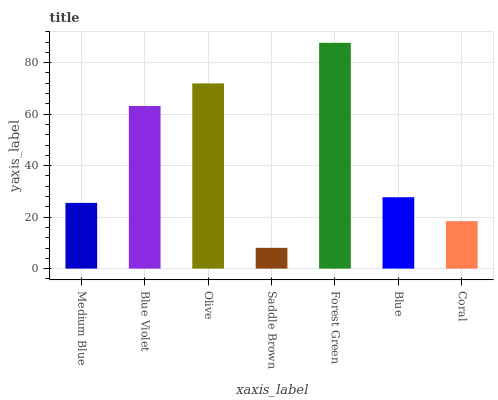Is Saddle Brown the minimum?
Answer yes or no. Yes. Is Forest Green the maximum?
Answer yes or no. Yes. Is Blue Violet the minimum?
Answer yes or no. No. Is Blue Violet the maximum?
Answer yes or no. No. Is Blue Violet greater than Medium Blue?
Answer yes or no. Yes. Is Medium Blue less than Blue Violet?
Answer yes or no. Yes. Is Medium Blue greater than Blue Violet?
Answer yes or no. No. Is Blue Violet less than Medium Blue?
Answer yes or no. No. Is Blue the high median?
Answer yes or no. Yes. Is Blue the low median?
Answer yes or no. Yes. Is Forest Green the high median?
Answer yes or no. No. Is Olive the low median?
Answer yes or no. No. 